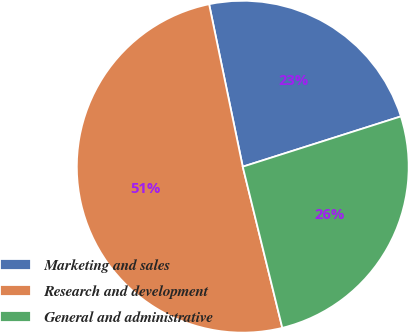Convert chart to OTSL. <chart><loc_0><loc_0><loc_500><loc_500><pie_chart><fcel>Marketing and sales<fcel>Research and development<fcel>General and administrative<nl><fcel>23.35%<fcel>50.58%<fcel>26.07%<nl></chart> 